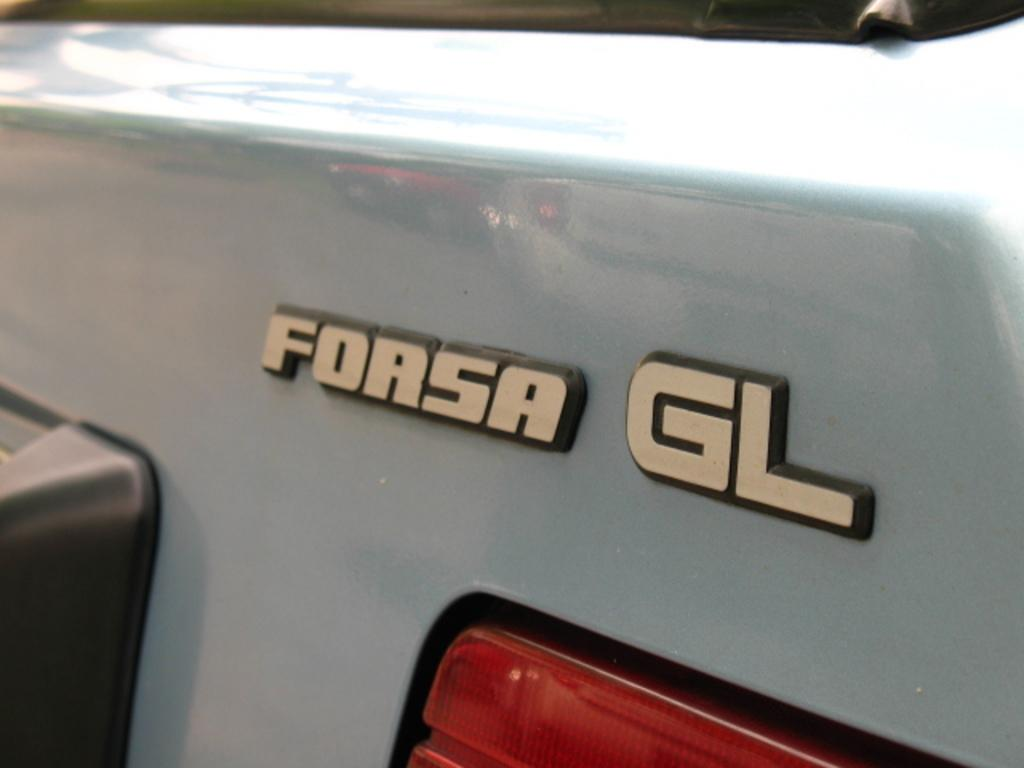What is the main subject of the image? The main subject of the image is a vehicle. What specific feature can be seen on the vehicle? The vehicle has a headlight. Is there any text present on the vehicle? Yes, there is text on the vehicle. What type of gold ornament is hanging from the vehicle's rearview mirror in the image? There is no mention of a gold ornament or a rearview mirror in the image, so we cannot answer this question. 